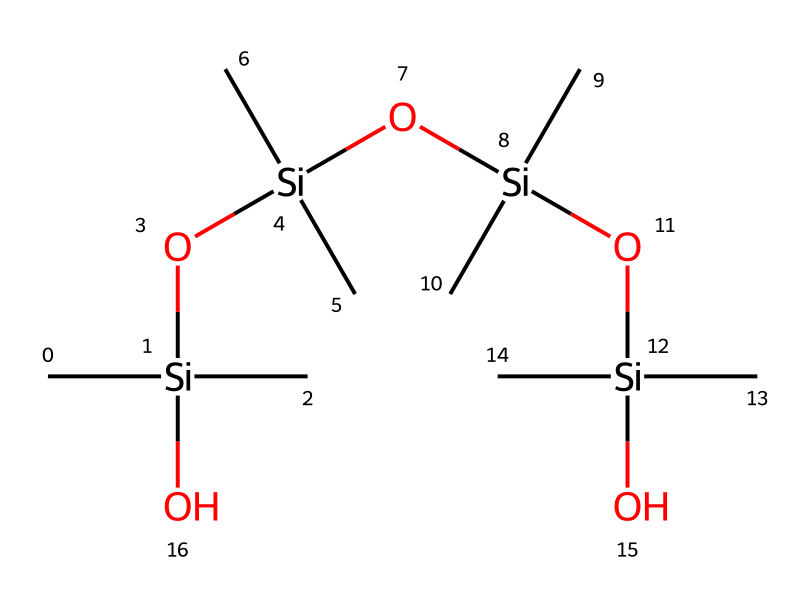How many silicon atoms are present in this chemical? By examining the given SMILES representation, we count how many silicon (Si) atoms appear. There are four "Si" entries in the structure.
Answer: four What functional groups are present in this chemical? In the SMILES, we see "O" which indicates the presence of hydroxyl (-OH) groups. The presence of these oxygen atoms bonded to silicon indicates silanol groups.
Answer: silanol What is the main chemical type of this structure? The primary component represented is silicon-based, as indicated by the fact that silicon is the central atom with surrounding carbon and oxygen. This categorizes it as a silane.
Answer: silane How many oxygen atoms are present in this chemical? Reviewing the structure, we find that there are four "O" entries corresponding to the oxygen atoms in the chemical.
Answer: four What property does the branching structure of this chemical confer? The extensive branching of the carbon and silicon framework suggests flexibility and lower surface energy, leading this silane to have good adhesion and sealing properties.
Answer: flexibility What is the significance of the repeated units in this chemical structure? The repeating units imply a polymeric nature, which usually enhances the durability and effectiveness of silicone sealants in preserving structures against moisture and weathering.
Answer: polymeric nature 